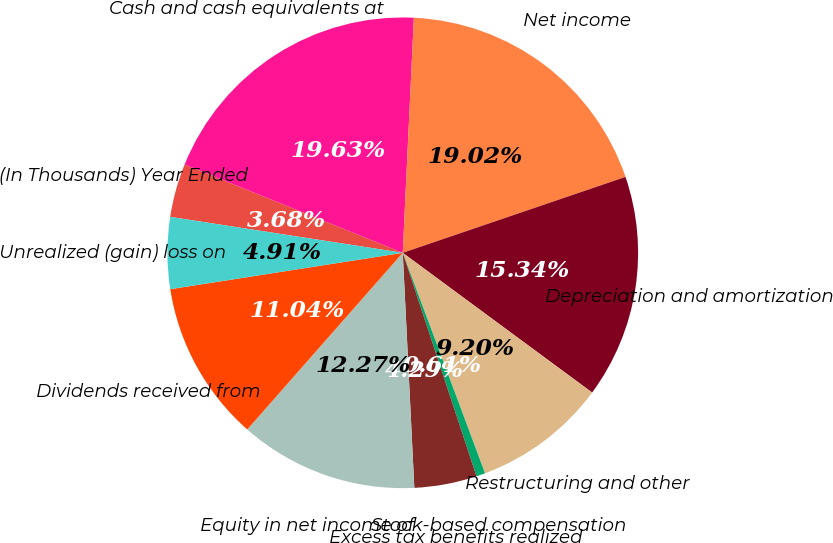<chart> <loc_0><loc_0><loc_500><loc_500><pie_chart><fcel>(In Thousands) Year Ended<fcel>Cash and cash equivalents at<fcel>Net income<fcel>Depreciation and amortization<fcel>Restructuring and other<fcel>Stock-based compensation<fcel>Excess tax benefits realized<fcel>Equity in net income of<fcel>Dividends received from<fcel>Unrealized (gain) loss on<nl><fcel>3.68%<fcel>19.63%<fcel>19.02%<fcel>15.34%<fcel>9.2%<fcel>0.61%<fcel>4.29%<fcel>12.27%<fcel>11.04%<fcel>4.91%<nl></chart> 